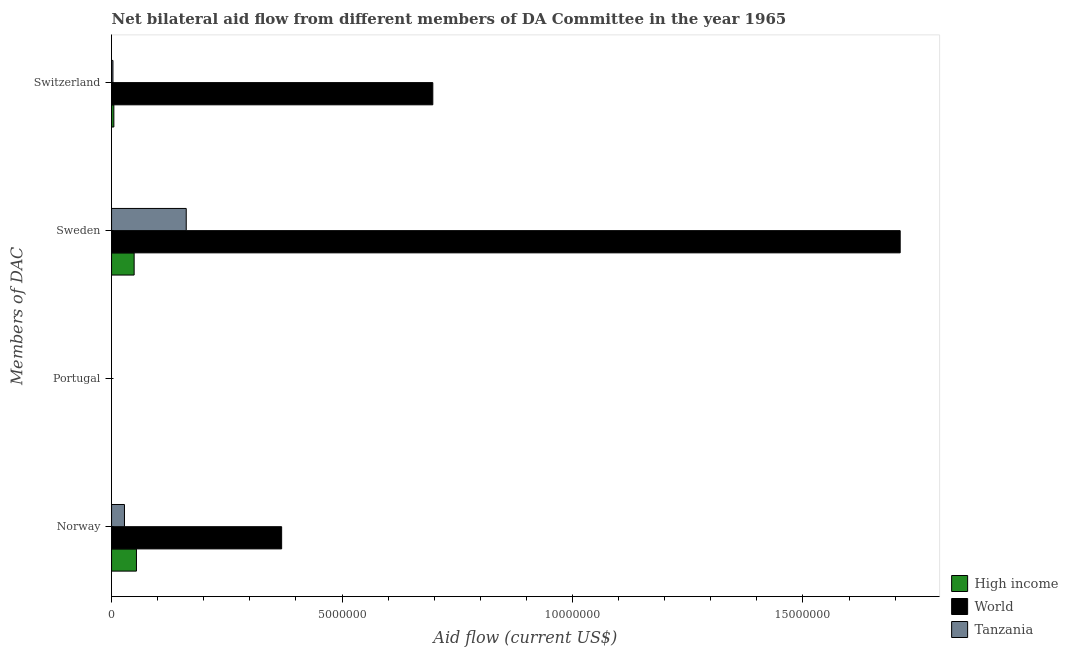How many different coloured bars are there?
Make the answer very short. 3. How many bars are there on the 1st tick from the top?
Your response must be concise. 3. What is the label of the 3rd group of bars from the top?
Your answer should be very brief. Portugal. What is the amount of aid given by norway in High income?
Your response must be concise. 5.40e+05. Across all countries, what is the maximum amount of aid given by sweden?
Your answer should be very brief. 1.71e+07. Across all countries, what is the minimum amount of aid given by switzerland?
Offer a terse response. 3.00e+04. What is the total amount of aid given by switzerland in the graph?
Your answer should be compact. 7.05e+06. What is the difference between the amount of aid given by switzerland in World and that in Tanzania?
Give a very brief answer. 6.94e+06. What is the difference between the amount of aid given by norway in High income and the amount of aid given by switzerland in Tanzania?
Make the answer very short. 5.10e+05. What is the difference between the amount of aid given by sweden and amount of aid given by norway in Tanzania?
Provide a short and direct response. 1.34e+06. In how many countries, is the amount of aid given by norway greater than 8000000 US$?
Provide a succinct answer. 0. What is the ratio of the amount of aid given by switzerland in Tanzania to that in World?
Ensure brevity in your answer.  0. Is the amount of aid given by sweden in Tanzania less than that in World?
Ensure brevity in your answer.  Yes. What is the difference between the highest and the second highest amount of aid given by switzerland?
Provide a succinct answer. 6.92e+06. What is the difference between the highest and the lowest amount of aid given by sweden?
Ensure brevity in your answer.  1.66e+07. Is it the case that in every country, the sum of the amount of aid given by norway and amount of aid given by portugal is greater than the amount of aid given by sweden?
Your response must be concise. No. How many bars are there?
Provide a short and direct response. 12. Are all the bars in the graph horizontal?
Give a very brief answer. Yes. How many countries are there in the graph?
Give a very brief answer. 3. What is the difference between two consecutive major ticks on the X-axis?
Your response must be concise. 5.00e+06. Are the values on the major ticks of X-axis written in scientific E-notation?
Offer a terse response. No. Does the graph contain any zero values?
Offer a terse response. Yes. Does the graph contain grids?
Keep it short and to the point. No. How are the legend labels stacked?
Provide a short and direct response. Vertical. What is the title of the graph?
Your response must be concise. Net bilateral aid flow from different members of DA Committee in the year 1965. What is the label or title of the X-axis?
Your answer should be very brief. Aid flow (current US$). What is the label or title of the Y-axis?
Give a very brief answer. Members of DAC. What is the Aid flow (current US$) in High income in Norway?
Your answer should be compact. 5.40e+05. What is the Aid flow (current US$) of World in Norway?
Give a very brief answer. 3.69e+06. What is the Aid flow (current US$) in Tanzania in Norway?
Make the answer very short. 2.80e+05. What is the Aid flow (current US$) in High income in Portugal?
Ensure brevity in your answer.  Nan. What is the Aid flow (current US$) in World in Portugal?
Offer a terse response. Nan. What is the Aid flow (current US$) in Tanzania in Portugal?
Your answer should be very brief. Nan. What is the Aid flow (current US$) in High income in Sweden?
Keep it short and to the point. 4.90e+05. What is the Aid flow (current US$) of World in Sweden?
Ensure brevity in your answer.  1.71e+07. What is the Aid flow (current US$) of Tanzania in Sweden?
Your response must be concise. 1.62e+06. What is the Aid flow (current US$) in World in Switzerland?
Make the answer very short. 6.97e+06. Across all Members of DAC, what is the maximum Aid flow (current US$) of High income?
Provide a short and direct response. 5.40e+05. Across all Members of DAC, what is the maximum Aid flow (current US$) in World?
Offer a terse response. 1.71e+07. Across all Members of DAC, what is the maximum Aid flow (current US$) in Tanzania?
Your answer should be compact. 1.62e+06. Across all Members of DAC, what is the minimum Aid flow (current US$) in High income?
Keep it short and to the point. 5.00e+04. Across all Members of DAC, what is the minimum Aid flow (current US$) in World?
Keep it short and to the point. 3.69e+06. Across all Members of DAC, what is the minimum Aid flow (current US$) in Tanzania?
Provide a short and direct response. 3.00e+04. What is the total Aid flow (current US$) in High income in the graph?
Offer a very short reply. 1.08e+06. What is the total Aid flow (current US$) in World in the graph?
Your answer should be compact. 2.78e+07. What is the total Aid flow (current US$) in Tanzania in the graph?
Your answer should be very brief. 1.93e+06. What is the difference between the Aid flow (current US$) of High income in Norway and that in Portugal?
Offer a terse response. Nan. What is the difference between the Aid flow (current US$) of World in Norway and that in Portugal?
Your answer should be very brief. Nan. What is the difference between the Aid flow (current US$) of Tanzania in Norway and that in Portugal?
Your answer should be compact. Nan. What is the difference between the Aid flow (current US$) in World in Norway and that in Sweden?
Provide a short and direct response. -1.34e+07. What is the difference between the Aid flow (current US$) in Tanzania in Norway and that in Sweden?
Your answer should be very brief. -1.34e+06. What is the difference between the Aid flow (current US$) of High income in Norway and that in Switzerland?
Offer a very short reply. 4.90e+05. What is the difference between the Aid flow (current US$) in World in Norway and that in Switzerland?
Provide a succinct answer. -3.28e+06. What is the difference between the Aid flow (current US$) in High income in Portugal and that in Sweden?
Make the answer very short. Nan. What is the difference between the Aid flow (current US$) of World in Portugal and that in Sweden?
Make the answer very short. Nan. What is the difference between the Aid flow (current US$) in Tanzania in Portugal and that in Sweden?
Provide a short and direct response. Nan. What is the difference between the Aid flow (current US$) of High income in Portugal and that in Switzerland?
Your answer should be compact. Nan. What is the difference between the Aid flow (current US$) of World in Portugal and that in Switzerland?
Provide a short and direct response. Nan. What is the difference between the Aid flow (current US$) in Tanzania in Portugal and that in Switzerland?
Keep it short and to the point. Nan. What is the difference between the Aid flow (current US$) in World in Sweden and that in Switzerland?
Provide a succinct answer. 1.01e+07. What is the difference between the Aid flow (current US$) in Tanzania in Sweden and that in Switzerland?
Offer a terse response. 1.59e+06. What is the difference between the Aid flow (current US$) of High income in Norway and the Aid flow (current US$) of World in Portugal?
Provide a short and direct response. Nan. What is the difference between the Aid flow (current US$) of High income in Norway and the Aid flow (current US$) of Tanzania in Portugal?
Provide a succinct answer. Nan. What is the difference between the Aid flow (current US$) of World in Norway and the Aid flow (current US$) of Tanzania in Portugal?
Keep it short and to the point. Nan. What is the difference between the Aid flow (current US$) in High income in Norway and the Aid flow (current US$) in World in Sweden?
Your answer should be very brief. -1.66e+07. What is the difference between the Aid flow (current US$) in High income in Norway and the Aid flow (current US$) in Tanzania in Sweden?
Ensure brevity in your answer.  -1.08e+06. What is the difference between the Aid flow (current US$) of World in Norway and the Aid flow (current US$) of Tanzania in Sweden?
Your answer should be compact. 2.07e+06. What is the difference between the Aid flow (current US$) of High income in Norway and the Aid flow (current US$) of World in Switzerland?
Provide a succinct answer. -6.43e+06. What is the difference between the Aid flow (current US$) of High income in Norway and the Aid flow (current US$) of Tanzania in Switzerland?
Keep it short and to the point. 5.10e+05. What is the difference between the Aid flow (current US$) of World in Norway and the Aid flow (current US$) of Tanzania in Switzerland?
Your answer should be compact. 3.66e+06. What is the difference between the Aid flow (current US$) in High income in Portugal and the Aid flow (current US$) in World in Sweden?
Your response must be concise. Nan. What is the difference between the Aid flow (current US$) in High income in Portugal and the Aid flow (current US$) in Tanzania in Sweden?
Ensure brevity in your answer.  Nan. What is the difference between the Aid flow (current US$) in World in Portugal and the Aid flow (current US$) in Tanzania in Sweden?
Provide a short and direct response. Nan. What is the difference between the Aid flow (current US$) of High income in Portugal and the Aid flow (current US$) of World in Switzerland?
Keep it short and to the point. Nan. What is the difference between the Aid flow (current US$) of High income in Portugal and the Aid flow (current US$) of Tanzania in Switzerland?
Provide a succinct answer. Nan. What is the difference between the Aid flow (current US$) of World in Portugal and the Aid flow (current US$) of Tanzania in Switzerland?
Your answer should be compact. Nan. What is the difference between the Aid flow (current US$) of High income in Sweden and the Aid flow (current US$) of World in Switzerland?
Your answer should be compact. -6.48e+06. What is the difference between the Aid flow (current US$) of World in Sweden and the Aid flow (current US$) of Tanzania in Switzerland?
Offer a very short reply. 1.71e+07. What is the average Aid flow (current US$) of High income per Members of DAC?
Your answer should be compact. 2.70e+05. What is the average Aid flow (current US$) of World per Members of DAC?
Provide a short and direct response. 6.94e+06. What is the average Aid flow (current US$) of Tanzania per Members of DAC?
Offer a very short reply. 4.82e+05. What is the difference between the Aid flow (current US$) of High income and Aid flow (current US$) of World in Norway?
Provide a short and direct response. -3.15e+06. What is the difference between the Aid flow (current US$) of High income and Aid flow (current US$) of Tanzania in Norway?
Offer a terse response. 2.60e+05. What is the difference between the Aid flow (current US$) of World and Aid flow (current US$) of Tanzania in Norway?
Offer a very short reply. 3.41e+06. What is the difference between the Aid flow (current US$) of High income and Aid flow (current US$) of World in Portugal?
Ensure brevity in your answer.  Nan. What is the difference between the Aid flow (current US$) of High income and Aid flow (current US$) of Tanzania in Portugal?
Ensure brevity in your answer.  Nan. What is the difference between the Aid flow (current US$) in World and Aid flow (current US$) in Tanzania in Portugal?
Offer a terse response. Nan. What is the difference between the Aid flow (current US$) in High income and Aid flow (current US$) in World in Sweden?
Give a very brief answer. -1.66e+07. What is the difference between the Aid flow (current US$) in High income and Aid flow (current US$) in Tanzania in Sweden?
Provide a short and direct response. -1.13e+06. What is the difference between the Aid flow (current US$) of World and Aid flow (current US$) of Tanzania in Sweden?
Offer a terse response. 1.55e+07. What is the difference between the Aid flow (current US$) in High income and Aid flow (current US$) in World in Switzerland?
Your response must be concise. -6.92e+06. What is the difference between the Aid flow (current US$) in World and Aid flow (current US$) in Tanzania in Switzerland?
Your answer should be very brief. 6.94e+06. What is the ratio of the Aid flow (current US$) of High income in Norway to that in Portugal?
Keep it short and to the point. Nan. What is the ratio of the Aid flow (current US$) in World in Norway to that in Portugal?
Keep it short and to the point. Nan. What is the ratio of the Aid flow (current US$) in Tanzania in Norway to that in Portugal?
Make the answer very short. Nan. What is the ratio of the Aid flow (current US$) in High income in Norway to that in Sweden?
Offer a very short reply. 1.1. What is the ratio of the Aid flow (current US$) of World in Norway to that in Sweden?
Your response must be concise. 0.22. What is the ratio of the Aid flow (current US$) of Tanzania in Norway to that in Sweden?
Your answer should be compact. 0.17. What is the ratio of the Aid flow (current US$) in High income in Norway to that in Switzerland?
Keep it short and to the point. 10.8. What is the ratio of the Aid flow (current US$) of World in Norway to that in Switzerland?
Provide a succinct answer. 0.53. What is the ratio of the Aid flow (current US$) of Tanzania in Norway to that in Switzerland?
Give a very brief answer. 9.33. What is the ratio of the Aid flow (current US$) of High income in Portugal to that in Sweden?
Your response must be concise. Nan. What is the ratio of the Aid flow (current US$) of World in Portugal to that in Sweden?
Ensure brevity in your answer.  Nan. What is the ratio of the Aid flow (current US$) in Tanzania in Portugal to that in Sweden?
Your answer should be compact. Nan. What is the ratio of the Aid flow (current US$) in High income in Portugal to that in Switzerland?
Offer a terse response. Nan. What is the ratio of the Aid flow (current US$) of World in Portugal to that in Switzerland?
Provide a short and direct response. Nan. What is the ratio of the Aid flow (current US$) in Tanzania in Portugal to that in Switzerland?
Offer a very short reply. Nan. What is the ratio of the Aid flow (current US$) in World in Sweden to that in Switzerland?
Make the answer very short. 2.45. What is the ratio of the Aid flow (current US$) in Tanzania in Sweden to that in Switzerland?
Your answer should be very brief. 54. What is the difference between the highest and the second highest Aid flow (current US$) of High income?
Provide a short and direct response. 5.00e+04. What is the difference between the highest and the second highest Aid flow (current US$) in World?
Offer a very short reply. 1.01e+07. What is the difference between the highest and the second highest Aid flow (current US$) in Tanzania?
Your answer should be very brief. 1.34e+06. What is the difference between the highest and the lowest Aid flow (current US$) in World?
Your answer should be very brief. 1.34e+07. What is the difference between the highest and the lowest Aid flow (current US$) of Tanzania?
Offer a very short reply. 1.59e+06. 